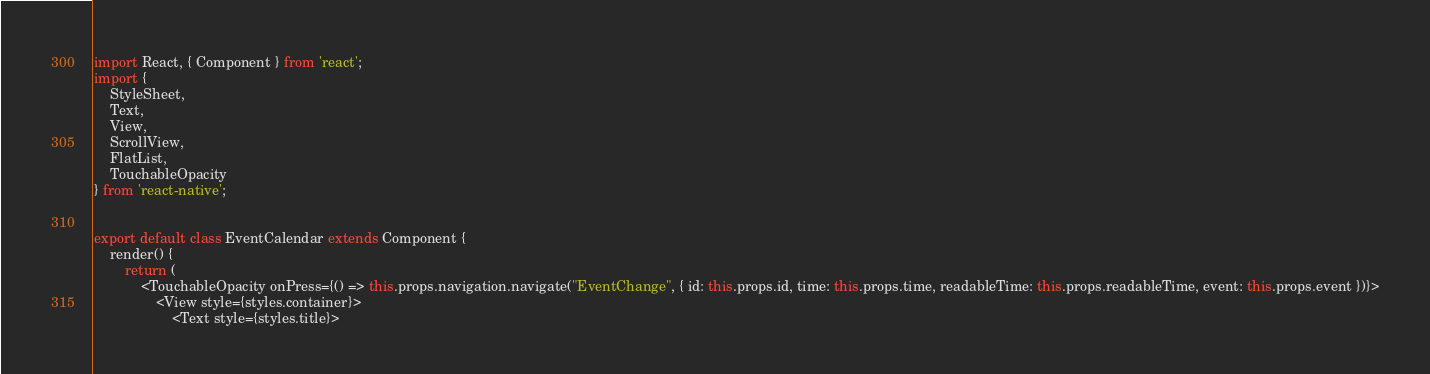Convert code to text. <code><loc_0><loc_0><loc_500><loc_500><_JavaScript_>import React, { Component } from 'react';
import {
    StyleSheet,
    Text,
    View,
    ScrollView,
    FlatList,
    TouchableOpacity
} from 'react-native';


export default class EventCalendar extends Component {
    render() {
        return (
            <TouchableOpacity onPress={() => this.props.navigation.navigate("EventChange", { id: this.props.id, time: this.props.time, readableTime: this.props.readableTime, event: this.props.event })}>
                <View style={styles.container}>
                    <Text style={styles.title}></code> 